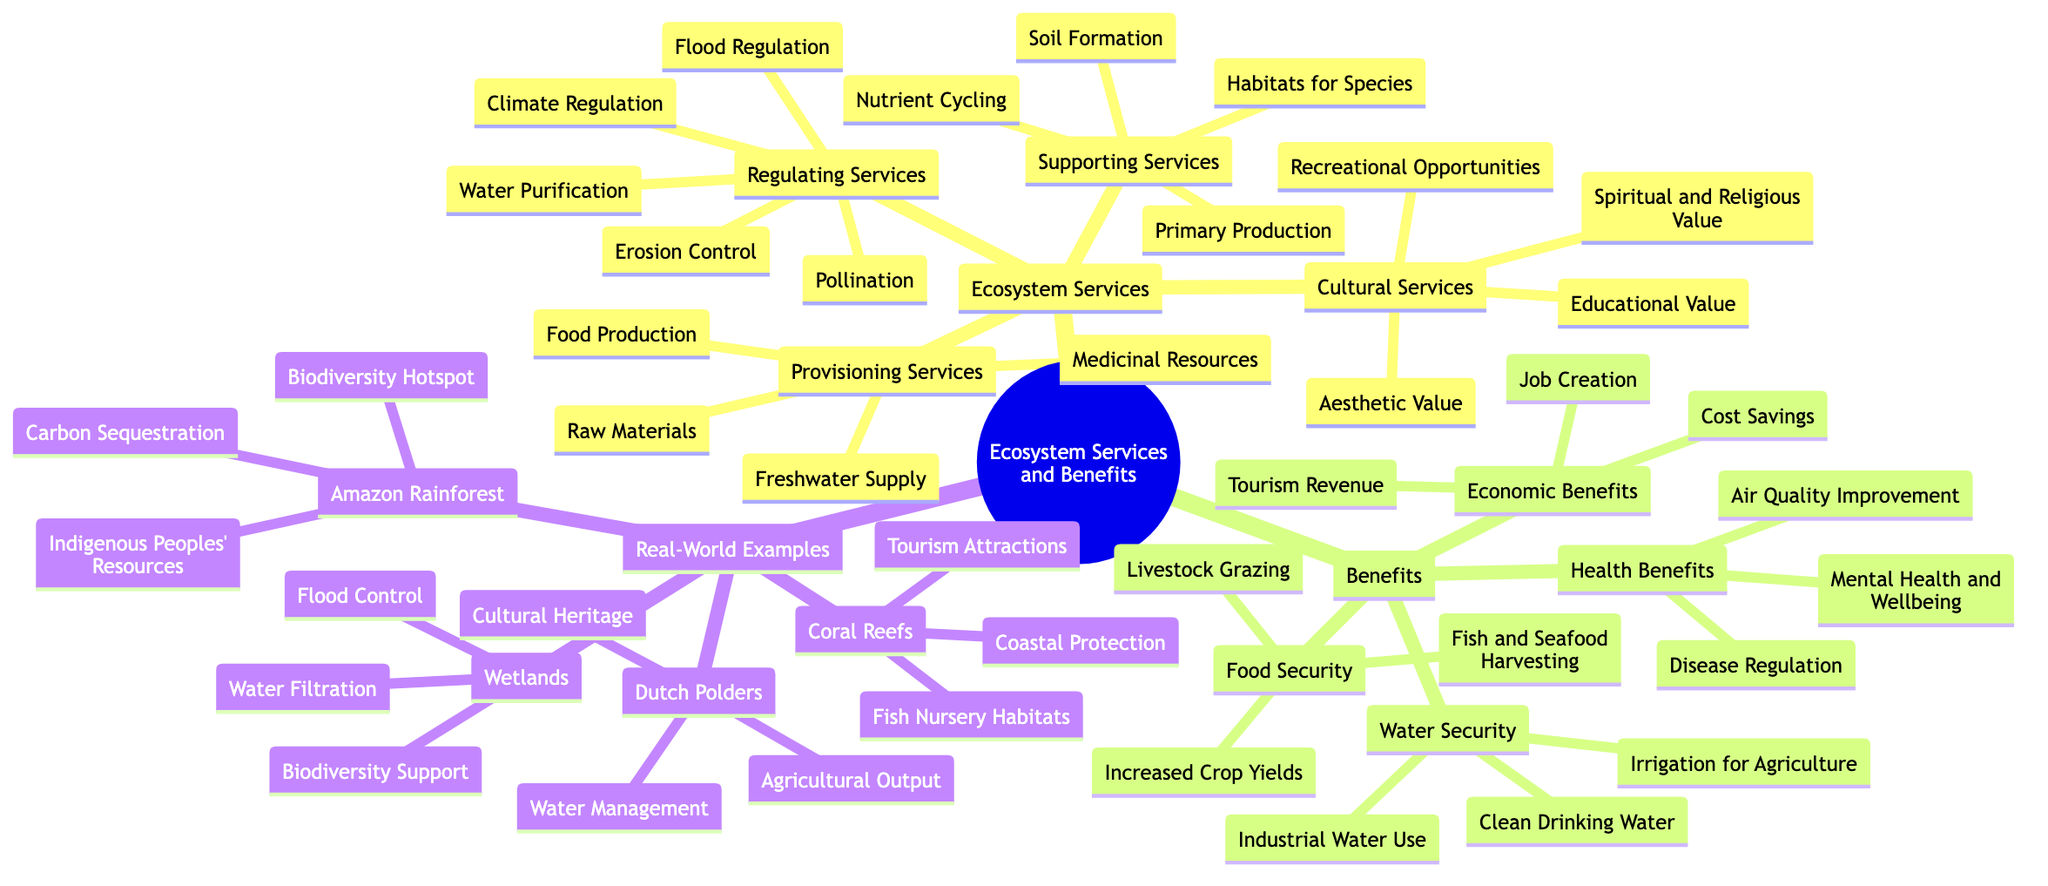What are the four categories of Ecosystem Services? The diagram lists four main categories under Ecosystem Services: Provisioning Services, Regulating Services, Cultural Services, and Supporting Services. Each category encompasses several specific services.
Answer: Provisioning Services, Regulating Services, Cultural Services, Supporting Services How many types of Health Benefits are mentioned in the diagram? The diagram shows three distinct types of Health Benefits, listed under the Benefits section as Air Quality Improvement, Disease Regulation, and Mental Health and Wellbeing.
Answer: 3 Which Ecosystem Service is associated with Flood Control? Flood Control is categorized under Regulating Services in the diagram. This links it directly to the service that helps manage and mitigate flood risks within ecosystems.
Answer: Flood Regulation Name two real-world examples of ecosystems that provide Tourism Attractions. The diagram lists Coral Reefs as one example with the service of Tourism Attractions. No other example explicitly mentions tourism. Hence, only one identified ecosystem is linked to this benefit.
Answer: Coral Reefs What is a benefit of wetlands related to water? The diagram specifies that wetlands provide Water Filtration, which is a key benefit associated with managing water quality and supply.
Answer: Water Filtration How do Supporting Services relate to Provisioning Services? Supporting Services, like Nutrient Cycling and Soil Formation, contribute to the conditions necessary for Provisioning Services such as Food Production and Freshwater Supply. Without the supporting services, the ability to produce food or provide freshwater would be compromised.
Answer: They facilitate Provisioning Services How many specific services are listed under Cultural Services? The diagram indicates four specific services under Cultural Services: Recreational Opportunities, Aesthetic Value, Educational Value, and Spiritual and Religious Value.
Answer: 4 What is the connection between Economic Benefits and Job Creation? The diagram categorizes Job Creation under Economic Benefits, indicating that job creation is a direct outcome of activities related to ecosystem services, such as tourism and agriculture.
Answer: Job Creation is under Economic Benefits 